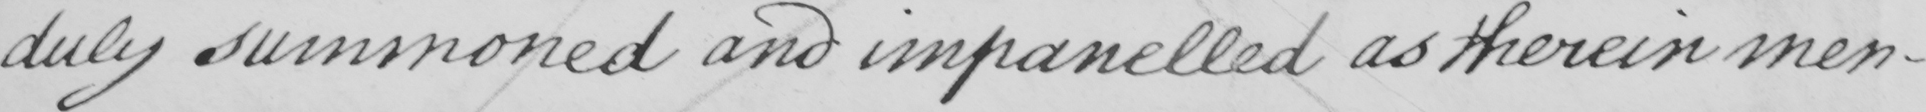What does this handwritten line say? duly summoned and impanelled as therein men- 